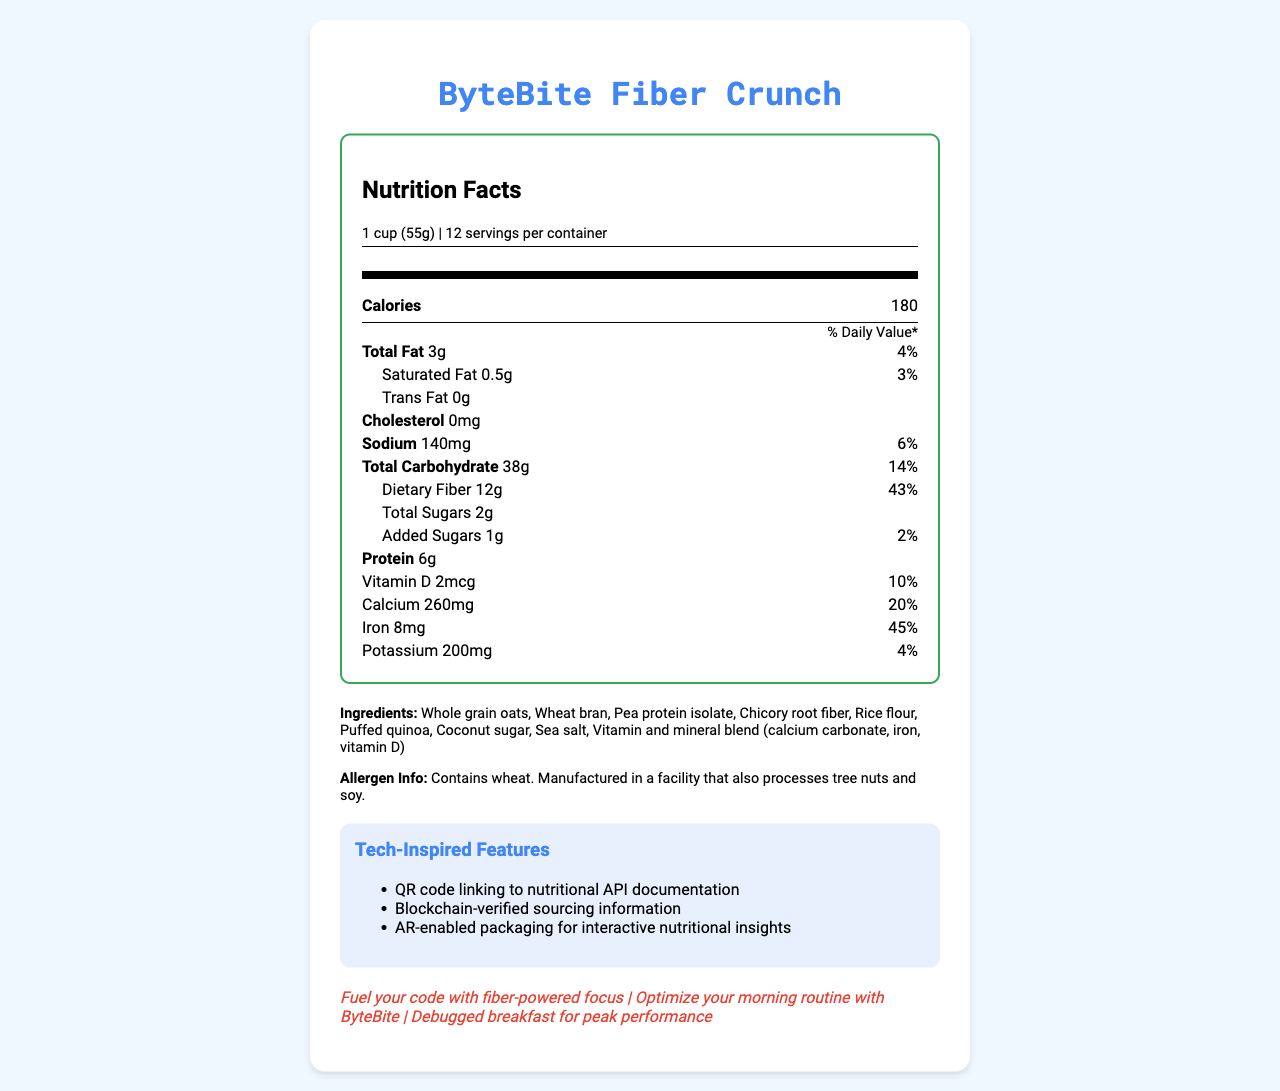What is the serving size of ByteBite Fiber Crunch? The serving size is clearly labeled as "1 cup (55g)" in the document.
Answer: 1 cup (55g) How many calories are there per serving? The document states that there are 180 calories per serving of ByteBite Fiber Crunch.
Answer: 180 How much dietary fiber is in one serving? The document lists dietary fiber content as 12g per serving.
Answer: 12g What is the Daily Value percentage for iron? The Daily Value percentage for iron is stated as 45% in the document.
Answer: 45% What are the three main health claims made about ByteBite Fiber Crunch? The document highlights these health claims about ByteBite Fiber Crunch.
Answer: Excellent source of fiber, Low in sugar, Good source of protein What is the amount of total carbohydrates per serving? The document indicates that there are 38g of total carbohydrates per serving.
Answer: 38g What are the ingredients used in ByteBite Fiber Crunch? The document lists all these ingredients used in ByteBite Fiber Crunch.
Answer: Whole grain oats, Wheat bran, Pea protein isolate, Chicory root fiber, Rice flour, Puffed quinoa, Coconut sugar, Sea salt, Vitamin and mineral blend (calcium carbonate, iron, vitamin D) Which of the following features are tech-inspired features of ByteBite Fiber Crunch? A. QR code linking to nutritional API documentation B. AR-enabled packaging for interactive nutritional insights C. Recyclable packaging D. Blockchain-verified sourcing information The tech-inspired features listed in the document include QR code linking to nutritional API documentation, AR-enabled packaging for interactive nutritional insights, and Blockchain-verified sourcing information.
Answer: A, B, D Which of the following allergens are present in ByteBite Fiber Crunch? A. Wheat B. Soy C. Tree nuts D. Dairy The allergen information indicates that ByteBite Fiber Crunch contains wheat.
Answer: A Is ByteBite Fiber Crunch low in sugar? The document claims ByteBite Fiber Crunch is low in sugar, with only 2g of total sugars per serving.
Answer: Yes Summarize the main features of ByteBite Fiber Crunch. The document provides a comprehensive overview of ByteBite Fiber Crunch, its nutritional benefits, ingredients, tech features, and marketing taglines targeting health-conscious tech professionals.
Answer: ByteBite Fiber Crunch is a low-sugar, high-fiber cereal designed for health-conscious tech professionals, featuring excellent sources of fiber, low sugar content, and good amounts of protein. It has tech-inspired features like QR codes, blockchain verification, and AR-enabled packaging. It's packaged sustainably and contains whole grain oats, wheat bran, and pea protein. What is the source of protein in ByteBite Fiber Crunch? The document lists pea protein isolate as one of the ingredients in ByteBite Fiber Crunch, which is a source of protein.
Answer: Pea protein isolate Who is the manufacturer of ByteBite Fiber Crunch? The document does not provide any information about the manufacturer of ByteBite Fiber Crunch.
Answer: Not enough information What are the marketing taglines associated with ByteBite Fiber Crunch? The document lists these three marketing taglines associated with ByteBite Fiber Crunch.
Answer: "Fuel your code with fiber-powered focus", "Optimize your morning routine with ByteBite", "Debugged breakfast for peak performance" How much calcium is in a serving of ByteBite Fiber Crunch? The document states that each serving contains 260mg of calcium.
Answer: 260mg 